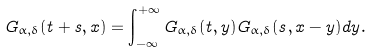Convert formula to latex. <formula><loc_0><loc_0><loc_500><loc_500>G _ { \alpha , \delta } ( t + s , x ) = \int _ { - \infty } ^ { + \infty } G _ { \alpha , \delta } ( t , y ) G _ { \alpha , \delta } ( s , x - y ) d y .</formula> 